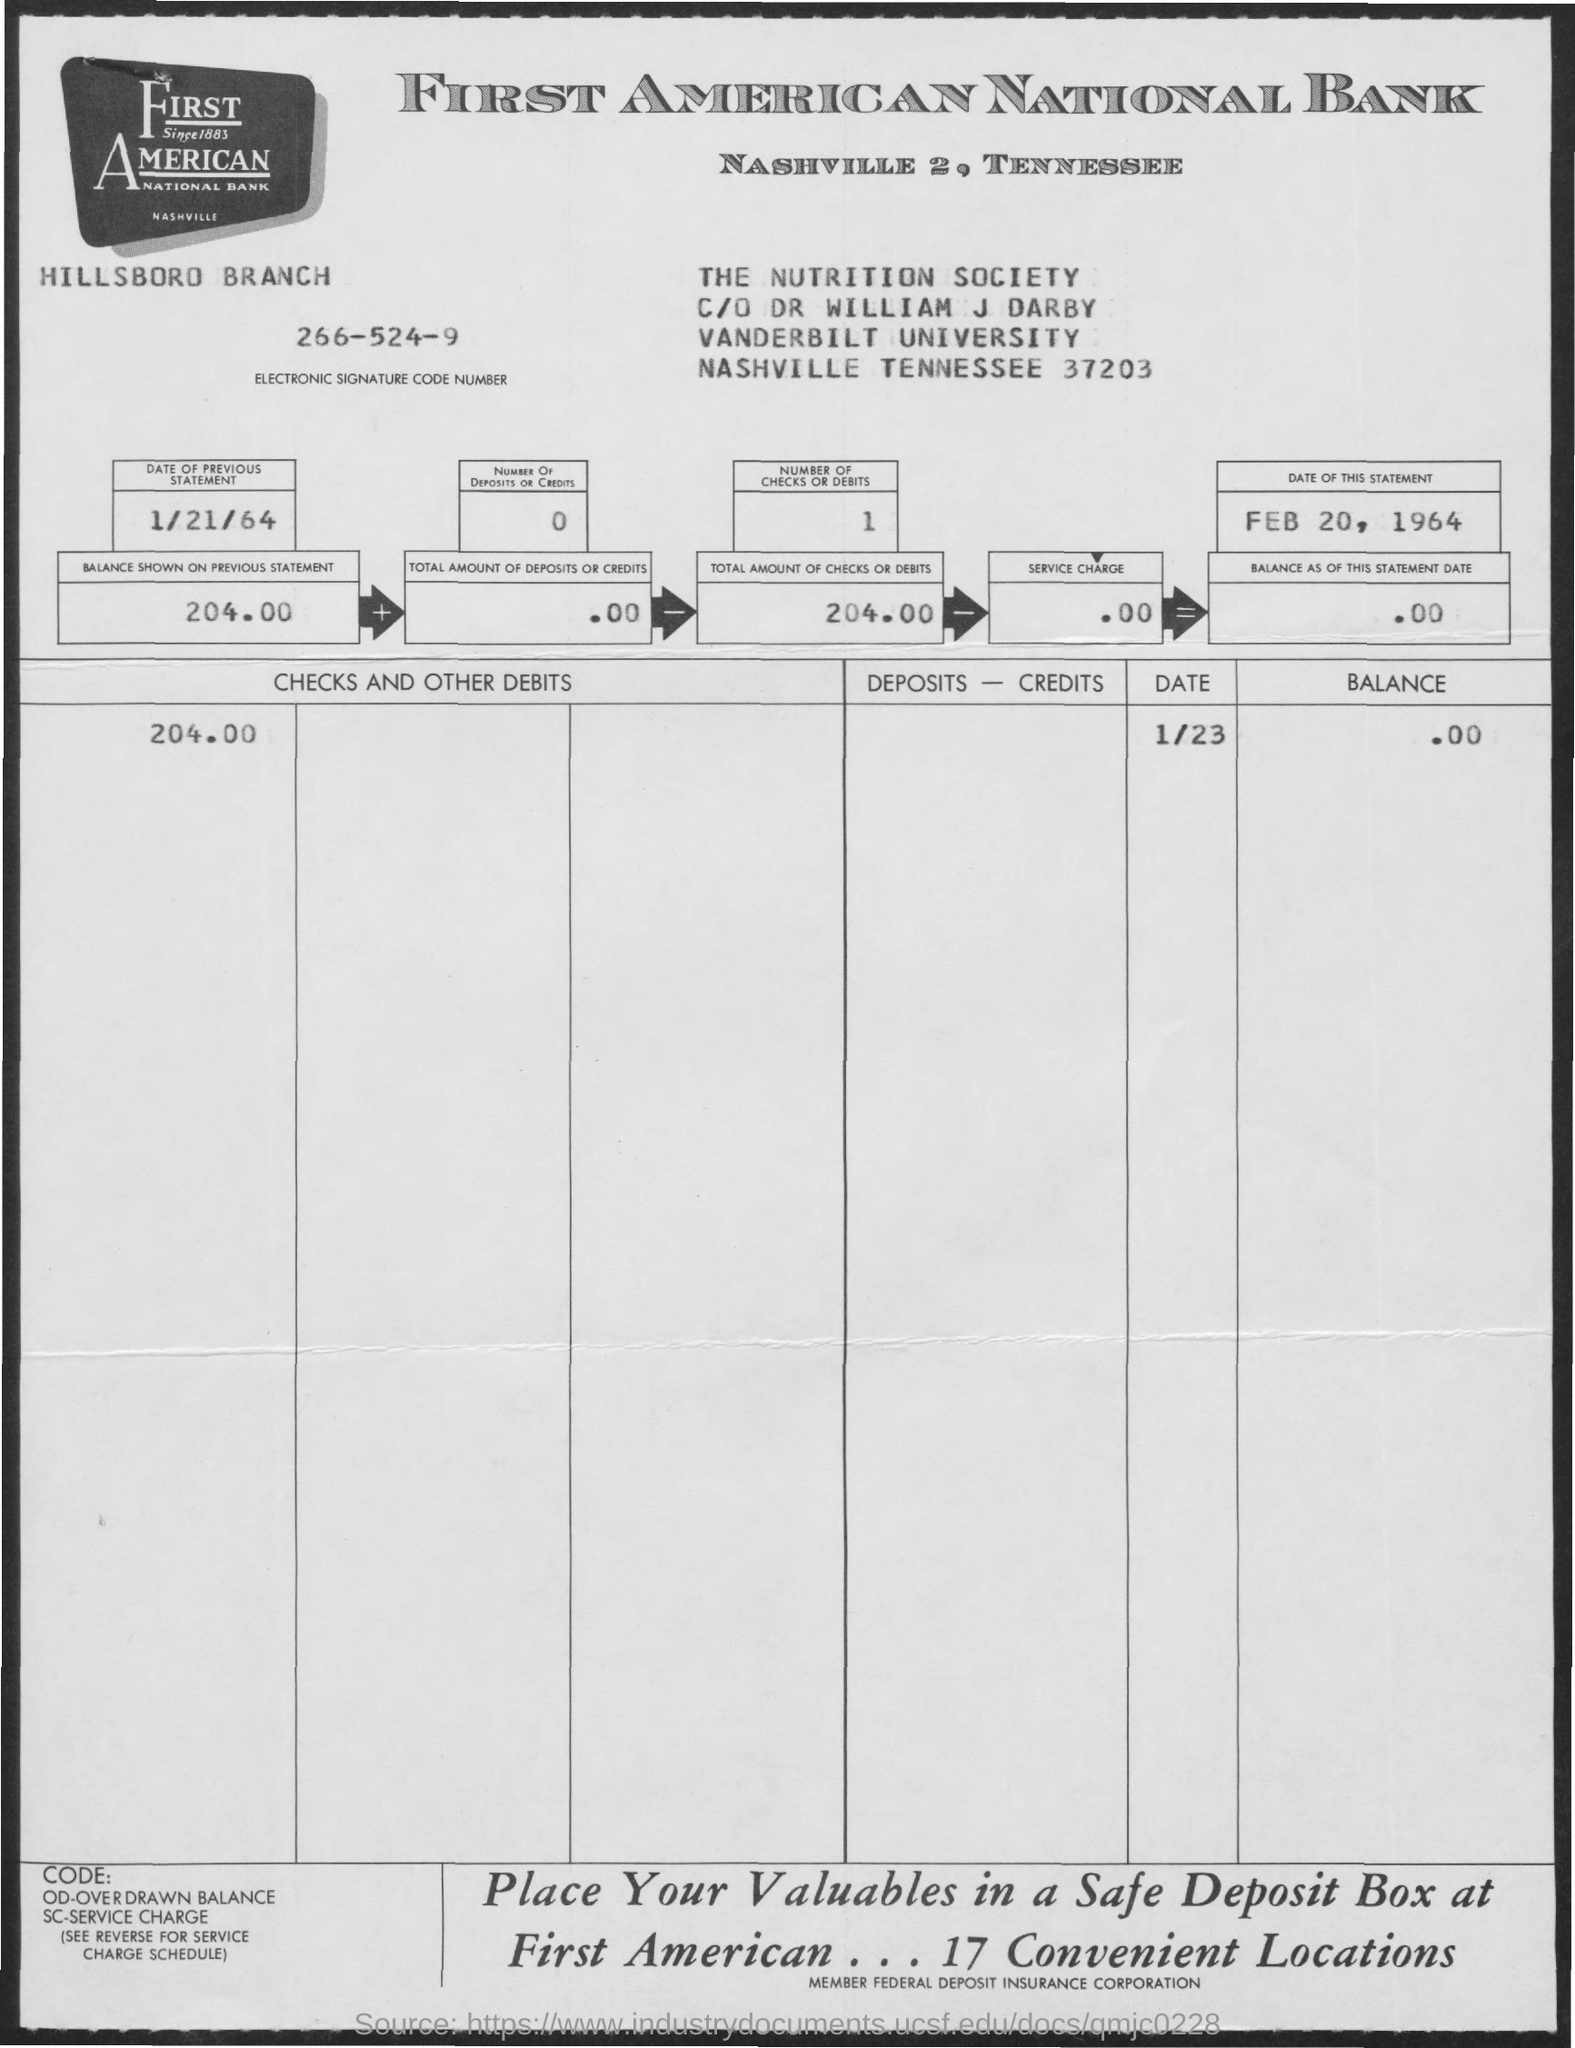Can you tell me more about the institution named on the statement? The institution on the bank statement is First American National Bank, located in Nashville, Tennessee. It appears to be an established bank, given its offer of a safe deposit box service at 17 convenient locations, suggesting a well-developed network within the area. This bank was likely an important financial entity in the region at the time. 